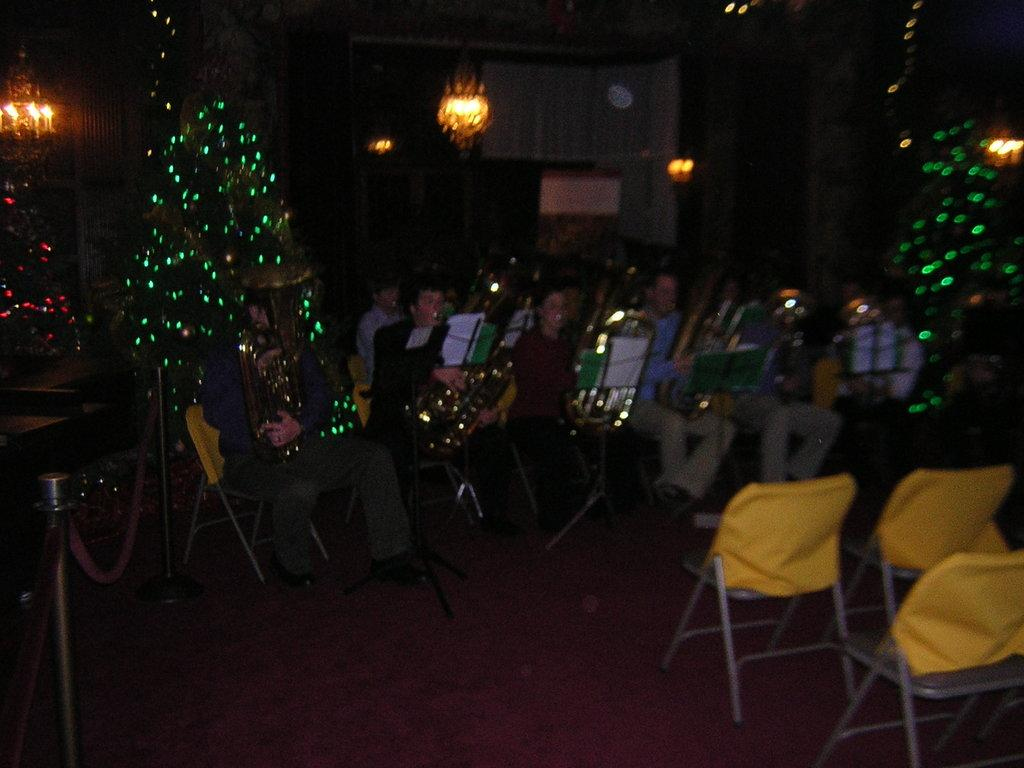What is the lighting condition in the image? The image is taken in a dark environment. What are the people in the image doing? The people are sitting on chairs and playing musical instruments. What can be seen in the background of the image? There are lights and candles visible in the background of the image. How many ducks are visible in the image? There are no ducks present in the image. What type of brain can be seen in the image? There is no brain visible in the image. 